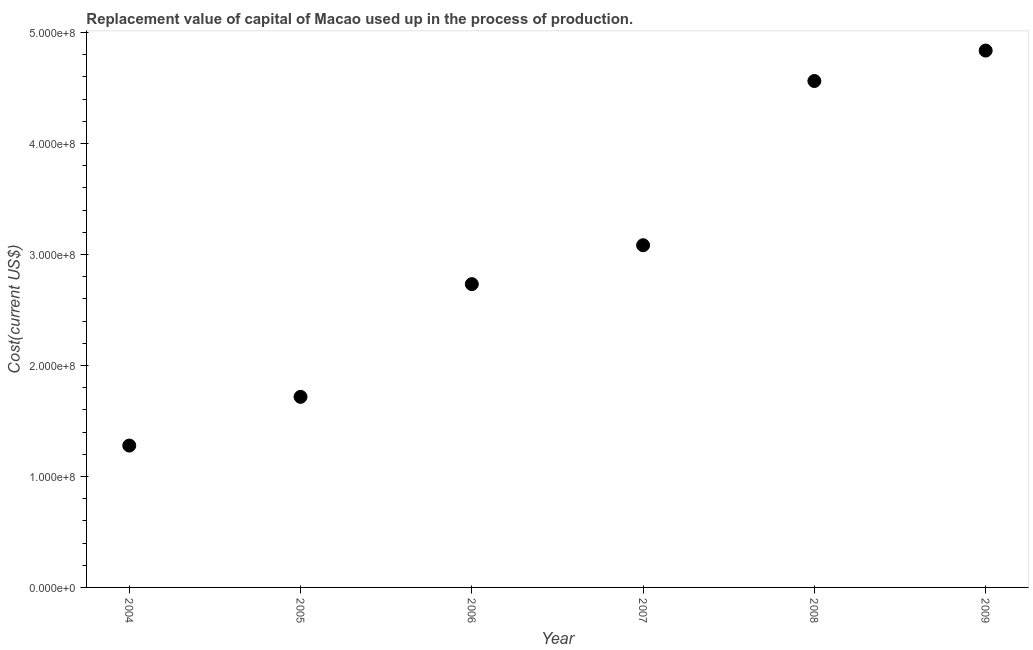What is the consumption of fixed capital in 2008?
Your response must be concise. 4.56e+08. Across all years, what is the maximum consumption of fixed capital?
Make the answer very short. 4.84e+08. Across all years, what is the minimum consumption of fixed capital?
Ensure brevity in your answer.  1.28e+08. In which year was the consumption of fixed capital minimum?
Make the answer very short. 2004. What is the sum of the consumption of fixed capital?
Keep it short and to the point. 1.82e+09. What is the difference between the consumption of fixed capital in 2008 and 2009?
Your answer should be very brief. -2.74e+07. What is the average consumption of fixed capital per year?
Your answer should be very brief. 3.04e+08. What is the median consumption of fixed capital?
Keep it short and to the point. 2.91e+08. Do a majority of the years between 2009 and 2005 (inclusive) have consumption of fixed capital greater than 40000000 US$?
Provide a succinct answer. Yes. What is the ratio of the consumption of fixed capital in 2005 to that in 2009?
Give a very brief answer. 0.35. What is the difference between the highest and the second highest consumption of fixed capital?
Offer a terse response. 2.74e+07. What is the difference between the highest and the lowest consumption of fixed capital?
Make the answer very short. 3.56e+08. In how many years, is the consumption of fixed capital greater than the average consumption of fixed capital taken over all years?
Your response must be concise. 3. What is the difference between two consecutive major ticks on the Y-axis?
Offer a terse response. 1.00e+08. Are the values on the major ticks of Y-axis written in scientific E-notation?
Give a very brief answer. Yes. Does the graph contain any zero values?
Offer a terse response. No. What is the title of the graph?
Your answer should be compact. Replacement value of capital of Macao used up in the process of production. What is the label or title of the Y-axis?
Provide a short and direct response. Cost(current US$). What is the Cost(current US$) in 2004?
Make the answer very short. 1.28e+08. What is the Cost(current US$) in 2005?
Your answer should be very brief. 1.72e+08. What is the Cost(current US$) in 2006?
Keep it short and to the point. 2.73e+08. What is the Cost(current US$) in 2007?
Your answer should be compact. 3.08e+08. What is the Cost(current US$) in 2008?
Your response must be concise. 4.56e+08. What is the Cost(current US$) in 2009?
Keep it short and to the point. 4.84e+08. What is the difference between the Cost(current US$) in 2004 and 2005?
Offer a very short reply. -4.39e+07. What is the difference between the Cost(current US$) in 2004 and 2006?
Ensure brevity in your answer.  -1.45e+08. What is the difference between the Cost(current US$) in 2004 and 2007?
Your answer should be compact. -1.81e+08. What is the difference between the Cost(current US$) in 2004 and 2008?
Keep it short and to the point. -3.29e+08. What is the difference between the Cost(current US$) in 2004 and 2009?
Your answer should be very brief. -3.56e+08. What is the difference between the Cost(current US$) in 2005 and 2006?
Make the answer very short. -1.02e+08. What is the difference between the Cost(current US$) in 2005 and 2007?
Your answer should be very brief. -1.37e+08. What is the difference between the Cost(current US$) in 2005 and 2008?
Provide a short and direct response. -2.85e+08. What is the difference between the Cost(current US$) in 2005 and 2009?
Your answer should be compact. -3.12e+08. What is the difference between the Cost(current US$) in 2006 and 2007?
Your response must be concise. -3.51e+07. What is the difference between the Cost(current US$) in 2006 and 2008?
Give a very brief answer. -1.83e+08. What is the difference between the Cost(current US$) in 2006 and 2009?
Offer a very short reply. -2.10e+08. What is the difference between the Cost(current US$) in 2007 and 2008?
Ensure brevity in your answer.  -1.48e+08. What is the difference between the Cost(current US$) in 2007 and 2009?
Offer a very short reply. -1.75e+08. What is the difference between the Cost(current US$) in 2008 and 2009?
Your answer should be very brief. -2.74e+07. What is the ratio of the Cost(current US$) in 2004 to that in 2005?
Provide a succinct answer. 0.74. What is the ratio of the Cost(current US$) in 2004 to that in 2006?
Make the answer very short. 0.47. What is the ratio of the Cost(current US$) in 2004 to that in 2007?
Your answer should be very brief. 0.41. What is the ratio of the Cost(current US$) in 2004 to that in 2008?
Your response must be concise. 0.28. What is the ratio of the Cost(current US$) in 2004 to that in 2009?
Your answer should be very brief. 0.26. What is the ratio of the Cost(current US$) in 2005 to that in 2006?
Make the answer very short. 0.63. What is the ratio of the Cost(current US$) in 2005 to that in 2007?
Ensure brevity in your answer.  0.56. What is the ratio of the Cost(current US$) in 2005 to that in 2008?
Your answer should be compact. 0.38. What is the ratio of the Cost(current US$) in 2005 to that in 2009?
Your response must be concise. 0.35. What is the ratio of the Cost(current US$) in 2006 to that in 2007?
Your answer should be compact. 0.89. What is the ratio of the Cost(current US$) in 2006 to that in 2008?
Ensure brevity in your answer.  0.6. What is the ratio of the Cost(current US$) in 2006 to that in 2009?
Keep it short and to the point. 0.56. What is the ratio of the Cost(current US$) in 2007 to that in 2008?
Your answer should be very brief. 0.68. What is the ratio of the Cost(current US$) in 2007 to that in 2009?
Make the answer very short. 0.64. What is the ratio of the Cost(current US$) in 2008 to that in 2009?
Keep it short and to the point. 0.94. 